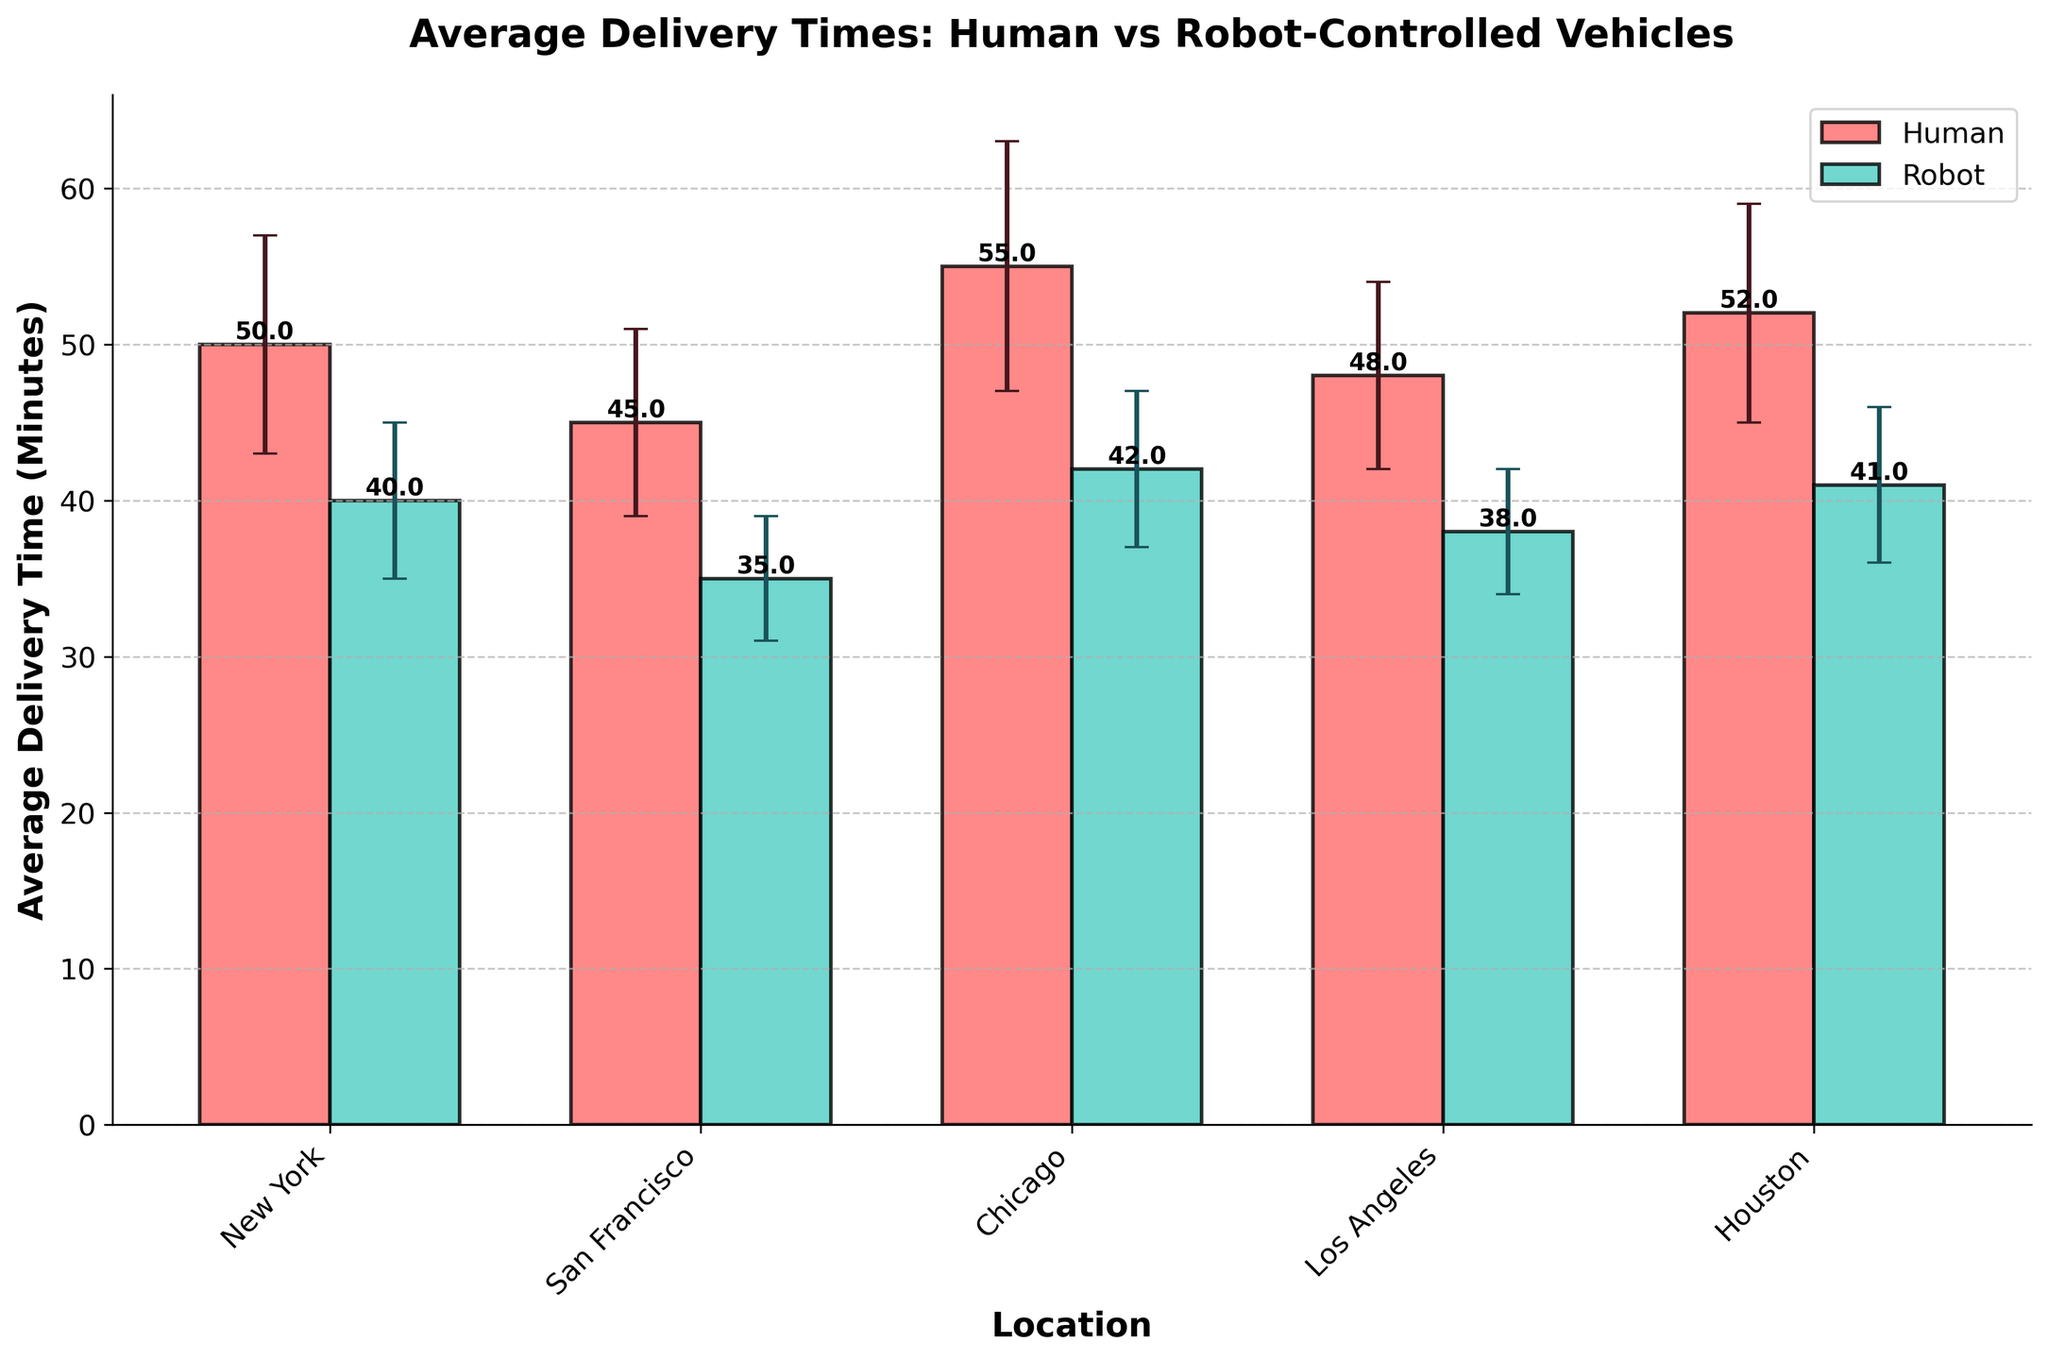what is the title of the plot? The title of the plot is displayed prominently at the top of the figure.
Answer: Average Delivery Times: Human vs Robot-Controlled Vehicles how many locations are compared in the chart? The x-axis displays the locations, and by counting these, we determine there are 5 locations.
Answer: 5 Which delivery type has a lower average delivery time in New York? New York is represented on the x-axis, and by looking at the heights of the bars for Human and Robot delivery types, the Robot bar is lower.
Answer: Robot What is the difference in average delivery time between Human and Robot vehicles in Los Angeles? For Los Angeles, find the bars labeled Human and Robot. The Human delivery time is 48 minutes, and the Robot delivery time is 38 minutes. Subtract to find the difference: 48 - 38 = 10.
Answer: 10 minutes Which location has the highest average delivery time for Human vehicles? By comparing the heights of the Human bars across all locations, the bar at Chicago is the tallest with an average delivery time of 55 minutes.
Answer: Chicago What is the range of the error margins for Human delivery times? Identify the error margins for Human vehicles: 7, 6, 8, 6, and 7. The minimum and maximum values are 6 and 8, respectively. Thus, the range is 8 - 6 = 2.
Answer: 2 minutes In which location are the error margins for Human vehicles visibly larger than those for Robot vehicles? By examining the error bars for both delivery types across locations, in Chicago, the Human error margin (8 minutes) appears visibly larger than the Robot error margin (5 minutes).
Answer: Chicago What is the average delivery time for Robot vehicles across all locations? Sum the delivery times for Robot vehicles (40 + 35 + 42 + 38 + 41) and divide by the number of locations (5): (40 + 35 + 42 + 38 + 41) / 5 = 39.2.
Answer: 39.2 minutes In which location do Robot vehicles have the smallest average delivery time? Compare the heights of the Robot bars to find San Francisco has the smallest average delivery time of 35 minutes.
Answer: San Francisco 